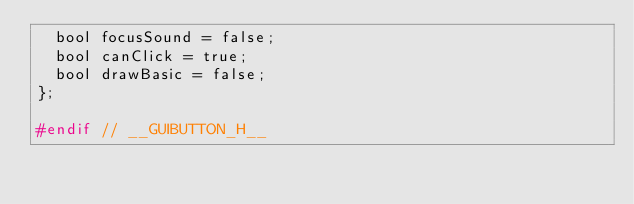Convert code to text. <code><loc_0><loc_0><loc_500><loc_500><_C_>	bool focusSound = false;
	bool canClick = true;
	bool drawBasic = false;
};

#endif // __GUIBUTTON_H__</code> 